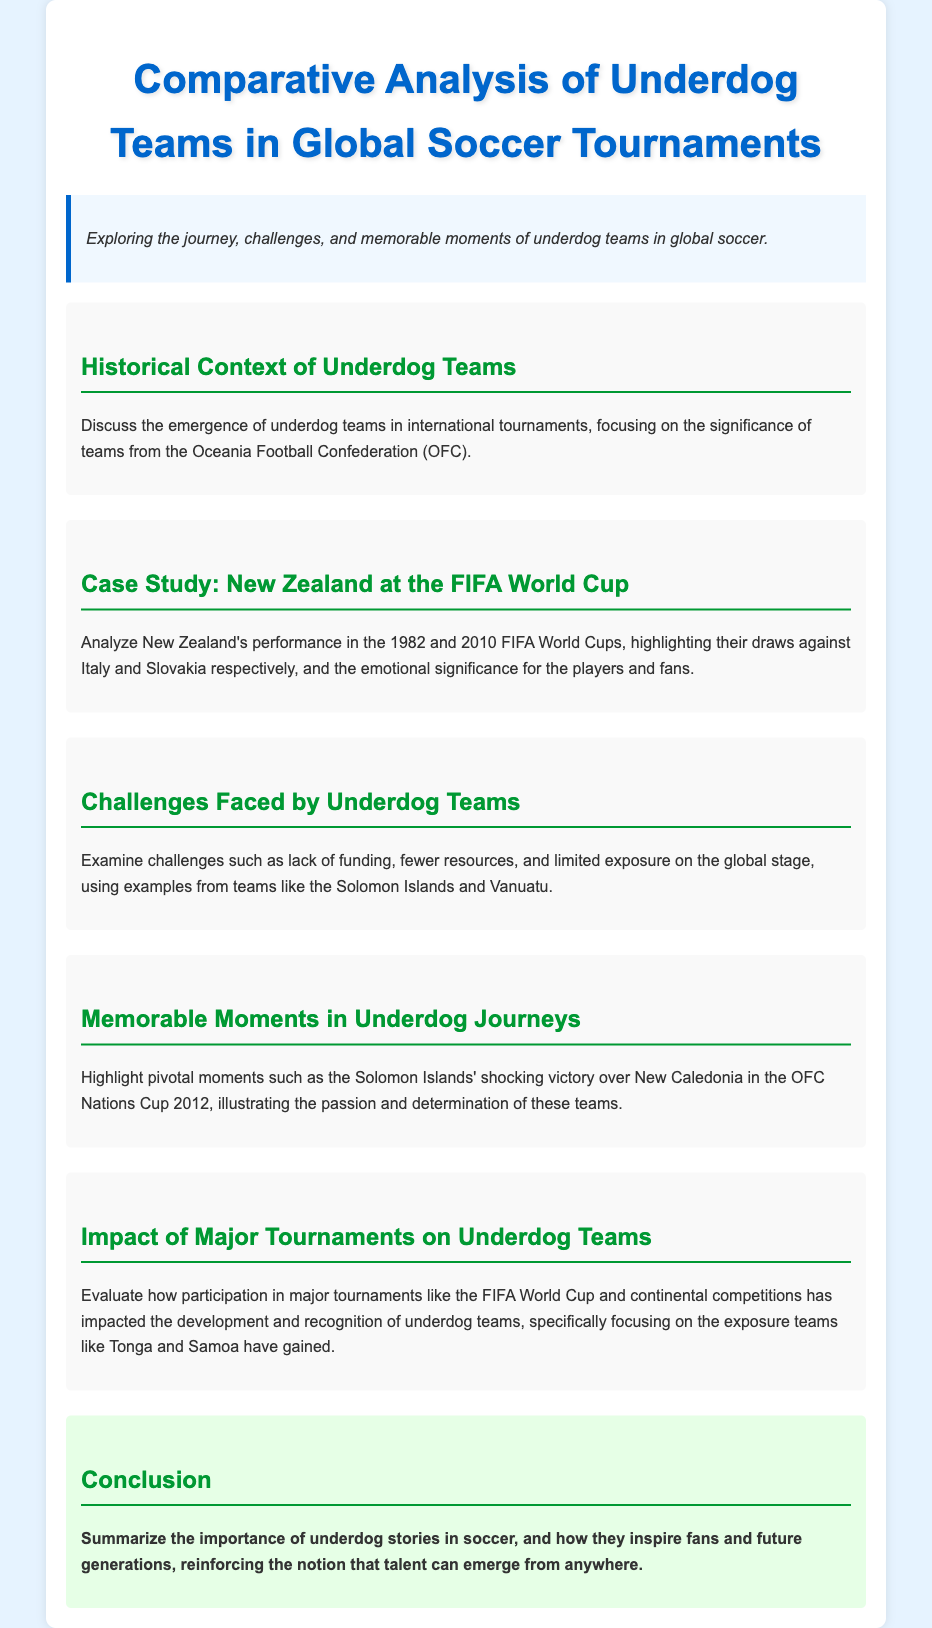What is the focus of the document? The document focuses on the journey, challenges, and memorable moments of underdog teams in global soccer.
Answer: Underdog teams in global soccer What is the first case study mentioned? The first case study mentioned is about New Zealand's performance in the FIFA World Cup.
Answer: New Zealand In which FIFA World Cups did New Zealand participate? The document specifies New Zealand's participation in the 1982 and 2010 FIFA World Cups.
Answer: 1982 and 2010 What significant result did New Zealand achieve in the 1982 World Cup? In the 1982 World Cup, New Zealand drew against Italy.
Answer: Drew against Italy Which underdog team's shocking victory is highlighted in the document? The document highlights the Solomon Islands' victory over New Caledonia.
Answer: Solomon Islands What are some challenges faced by underdog teams? Challenges include lack of funding, fewer resources, and limited exposure on the global stage.
Answer: Lack of funding, fewer resources, limited exposure What is the impact of major tournaments on underdog teams? Major tournaments increase development and recognition of underdog teams.
Answer: Development and recognition What is the conclusion's main point regarding underdog stories? The conclusion emphasizes the inspiration provided by underdog stories in soccer.
Answer: Inspiration for fans and future generations 